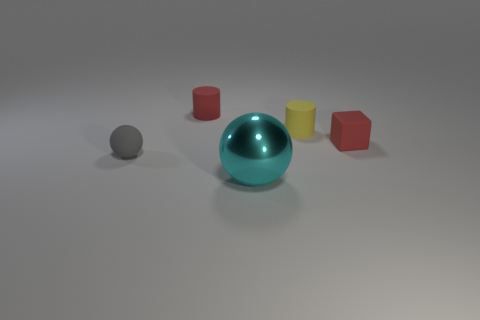Is there anything else that is the same material as the tiny yellow cylinder?
Your answer should be compact. Yes. Are any yellow cylinders visible?
Give a very brief answer. Yes. Is the material of the tiny object in front of the tiny cube the same as the yellow cylinder?
Your answer should be compact. Yes. Is there a brown metal thing that has the same shape as the yellow thing?
Your response must be concise. No. Are there an equal number of red things on the right side of the metallic ball and tiny blocks?
Provide a succinct answer. Yes. What is the ball on the left side of the ball in front of the tiny rubber sphere made of?
Offer a very short reply. Rubber. What is the shape of the gray object?
Your answer should be very brief. Sphere. Are there the same number of tiny red matte cylinders on the right side of the small gray matte sphere and blocks that are on the left side of the yellow matte thing?
Give a very brief answer. No. Do the rubber cylinder to the left of the yellow object and the small matte object right of the small yellow matte object have the same color?
Ensure brevity in your answer.  Yes. Is the number of red cylinders that are behind the metal ball greater than the number of big gray rubber spheres?
Provide a succinct answer. Yes. 